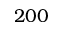Convert formula to latex. <formula><loc_0><loc_0><loc_500><loc_500>2 0 0</formula> 